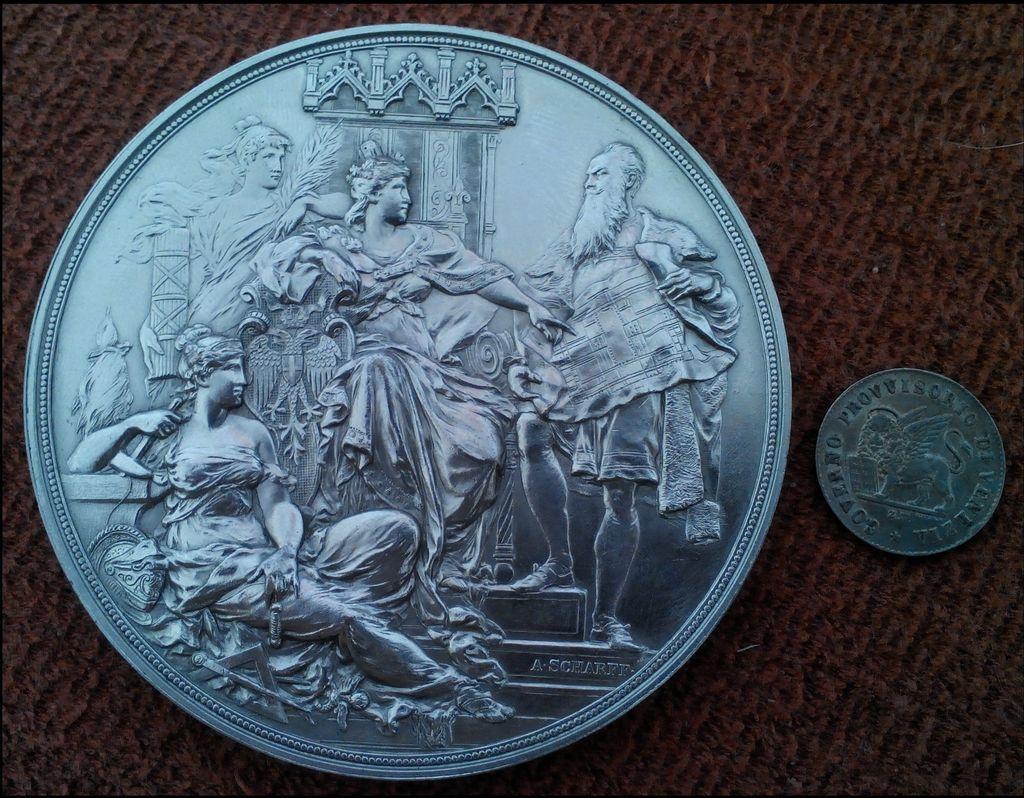Describe this image in one or two sentences. In this image there is a big coin on the left side and a small coin on the right side. On the coin there is an engraving of sculptures. 